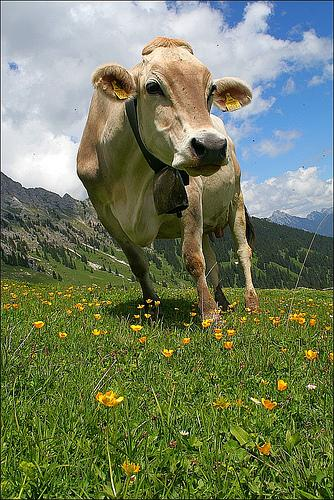Question: what is behind the cow?
Choices:
A. Mountains.
B. Valleys.
C. Trees.
D. A beach.
Answer with the letter. Answer: A Question: what is standing in the grass?
Choices:
A. Sheep.
B. A cow.
C. Dog.
D. Cat.
Answer with the letter. Answer: B Question: where are the flowers?
Choices:
A. On the trees.
B. The grass.
C. On the bushes.
D. In the vase.
Answer with the letter. Answer: B Question: what color are the tags in the cow's ears?
Choices:
A. Yellow.
B. Red.
C. Blue.
D. White.
Answer with the letter. Answer: A Question: how many ear tags?
Choices:
A. Three.
B. One.
C. None.
D. Two.
Answer with the letter. Answer: D Question: how is the sky?
Choices:
A. Clear.
B. Cloudy.
C. Sunny.
D. Rainy.
Answer with the letter. Answer: B 